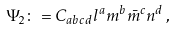<formula> <loc_0><loc_0><loc_500><loc_500>\Psi _ { 2 } \colon = C _ { a b c d } l ^ { a } m ^ { b } { \bar { m } } ^ { c } n ^ { d } \, ,</formula> 